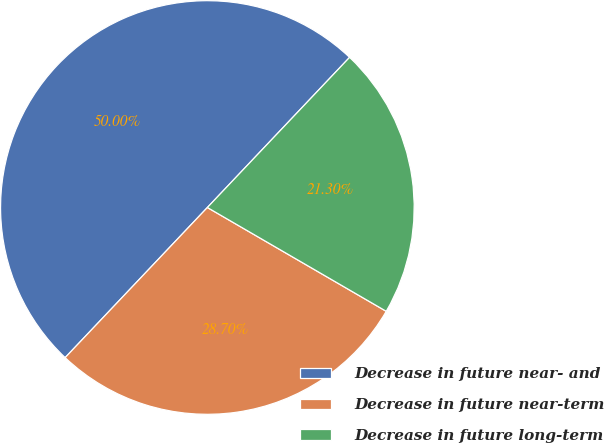Convert chart. <chart><loc_0><loc_0><loc_500><loc_500><pie_chart><fcel>Decrease in future near- and<fcel>Decrease in future near-term<fcel>Decrease in future long-term<nl><fcel>50.0%<fcel>28.7%<fcel>21.3%<nl></chart> 